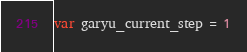Convert code to text. <code><loc_0><loc_0><loc_500><loc_500><_JavaScript_>var garyu_current_step = 1</code> 